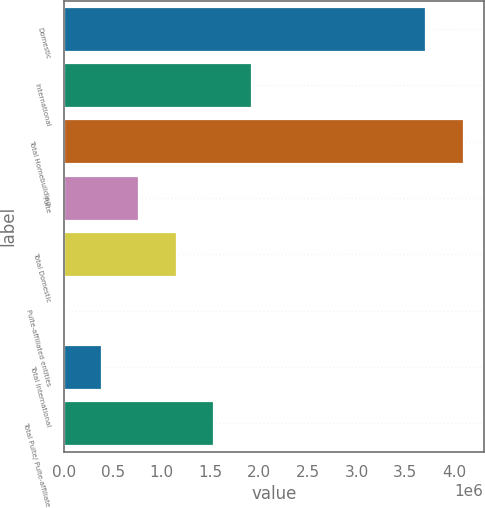Convert chart to OTSL. <chart><loc_0><loc_0><loc_500><loc_500><bar_chart><fcel>Domestic<fcel>International<fcel>Total Homebuilding<fcel>Pulte<fcel>Total Domestic<fcel>Pulte-affiliated entities<fcel>Total International<fcel>Total Pulte/ Pulte-affiliate<nl><fcel>3.71333e+06<fcel>1.92358e+06<fcel>4.09674e+06<fcel>773338<fcel>1.15675e+06<fcel>6512<fcel>389925<fcel>1.54016e+06<nl></chart> 